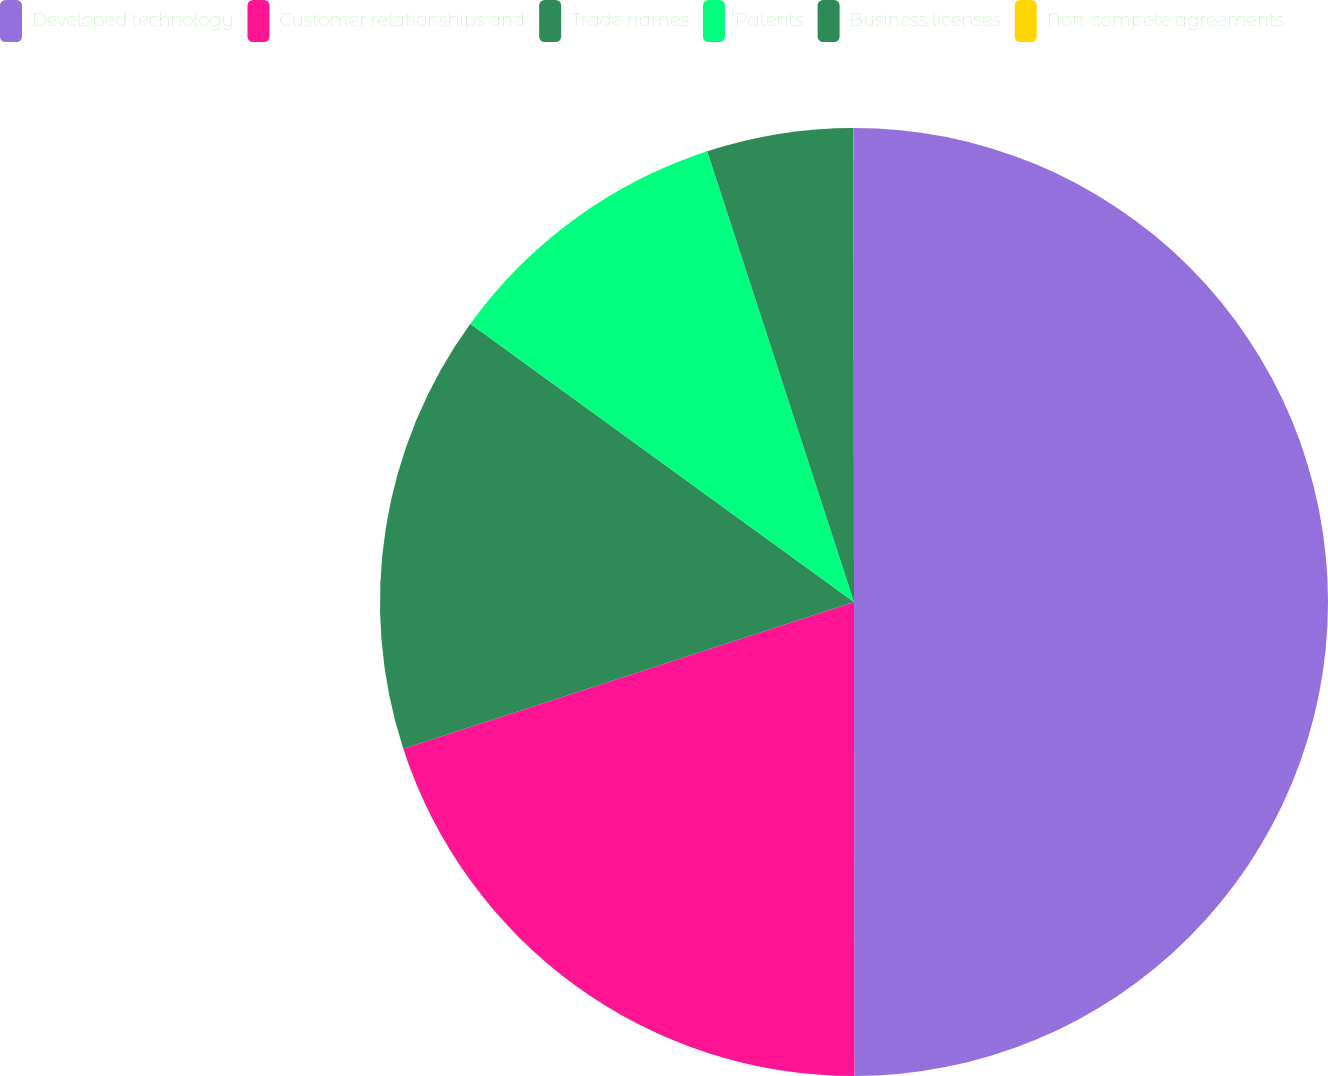Convert chart to OTSL. <chart><loc_0><loc_0><loc_500><loc_500><pie_chart><fcel>Developed technology<fcel>Customer relationships and<fcel>Trade names<fcel>Patents<fcel>Business licenses<fcel>Non-compete agreements<nl><fcel>49.99%<fcel>20.0%<fcel>15.0%<fcel>10.0%<fcel>5.0%<fcel>0.01%<nl></chart> 